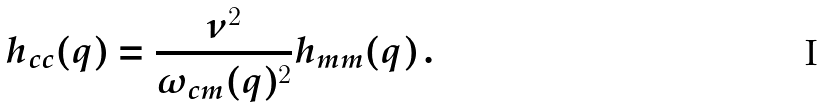Convert formula to latex. <formula><loc_0><loc_0><loc_500><loc_500>h _ { c c } ( q ) = \frac { \nu ^ { 2 } } { \omega _ { c m } ( q ) ^ { 2 } } h _ { m m } ( q ) \, .</formula> 